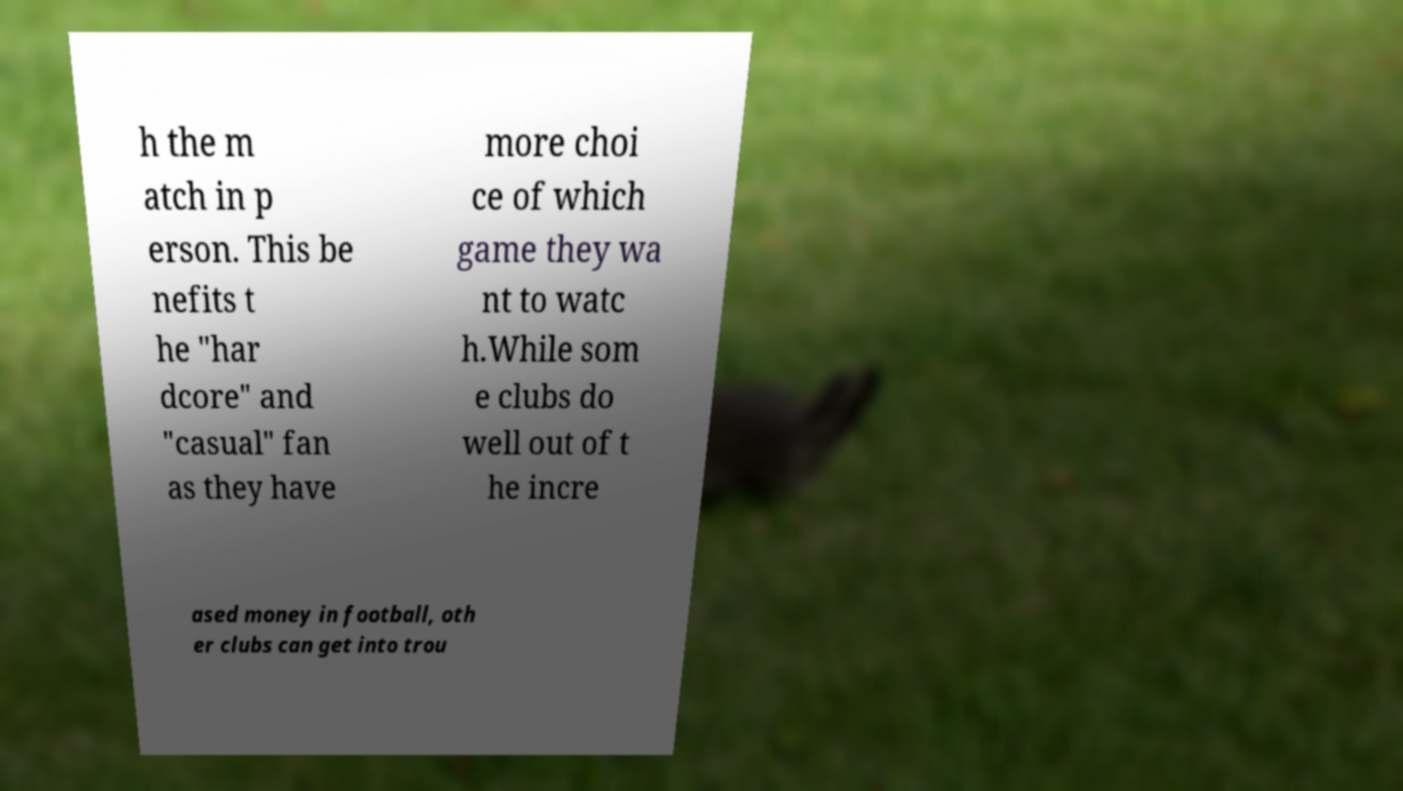Can you read and provide the text displayed in the image?This photo seems to have some interesting text. Can you extract and type it out for me? h the m atch in p erson. This be nefits t he "har dcore" and "casual" fan as they have more choi ce of which game they wa nt to watc h.While som e clubs do well out of t he incre ased money in football, oth er clubs can get into trou 